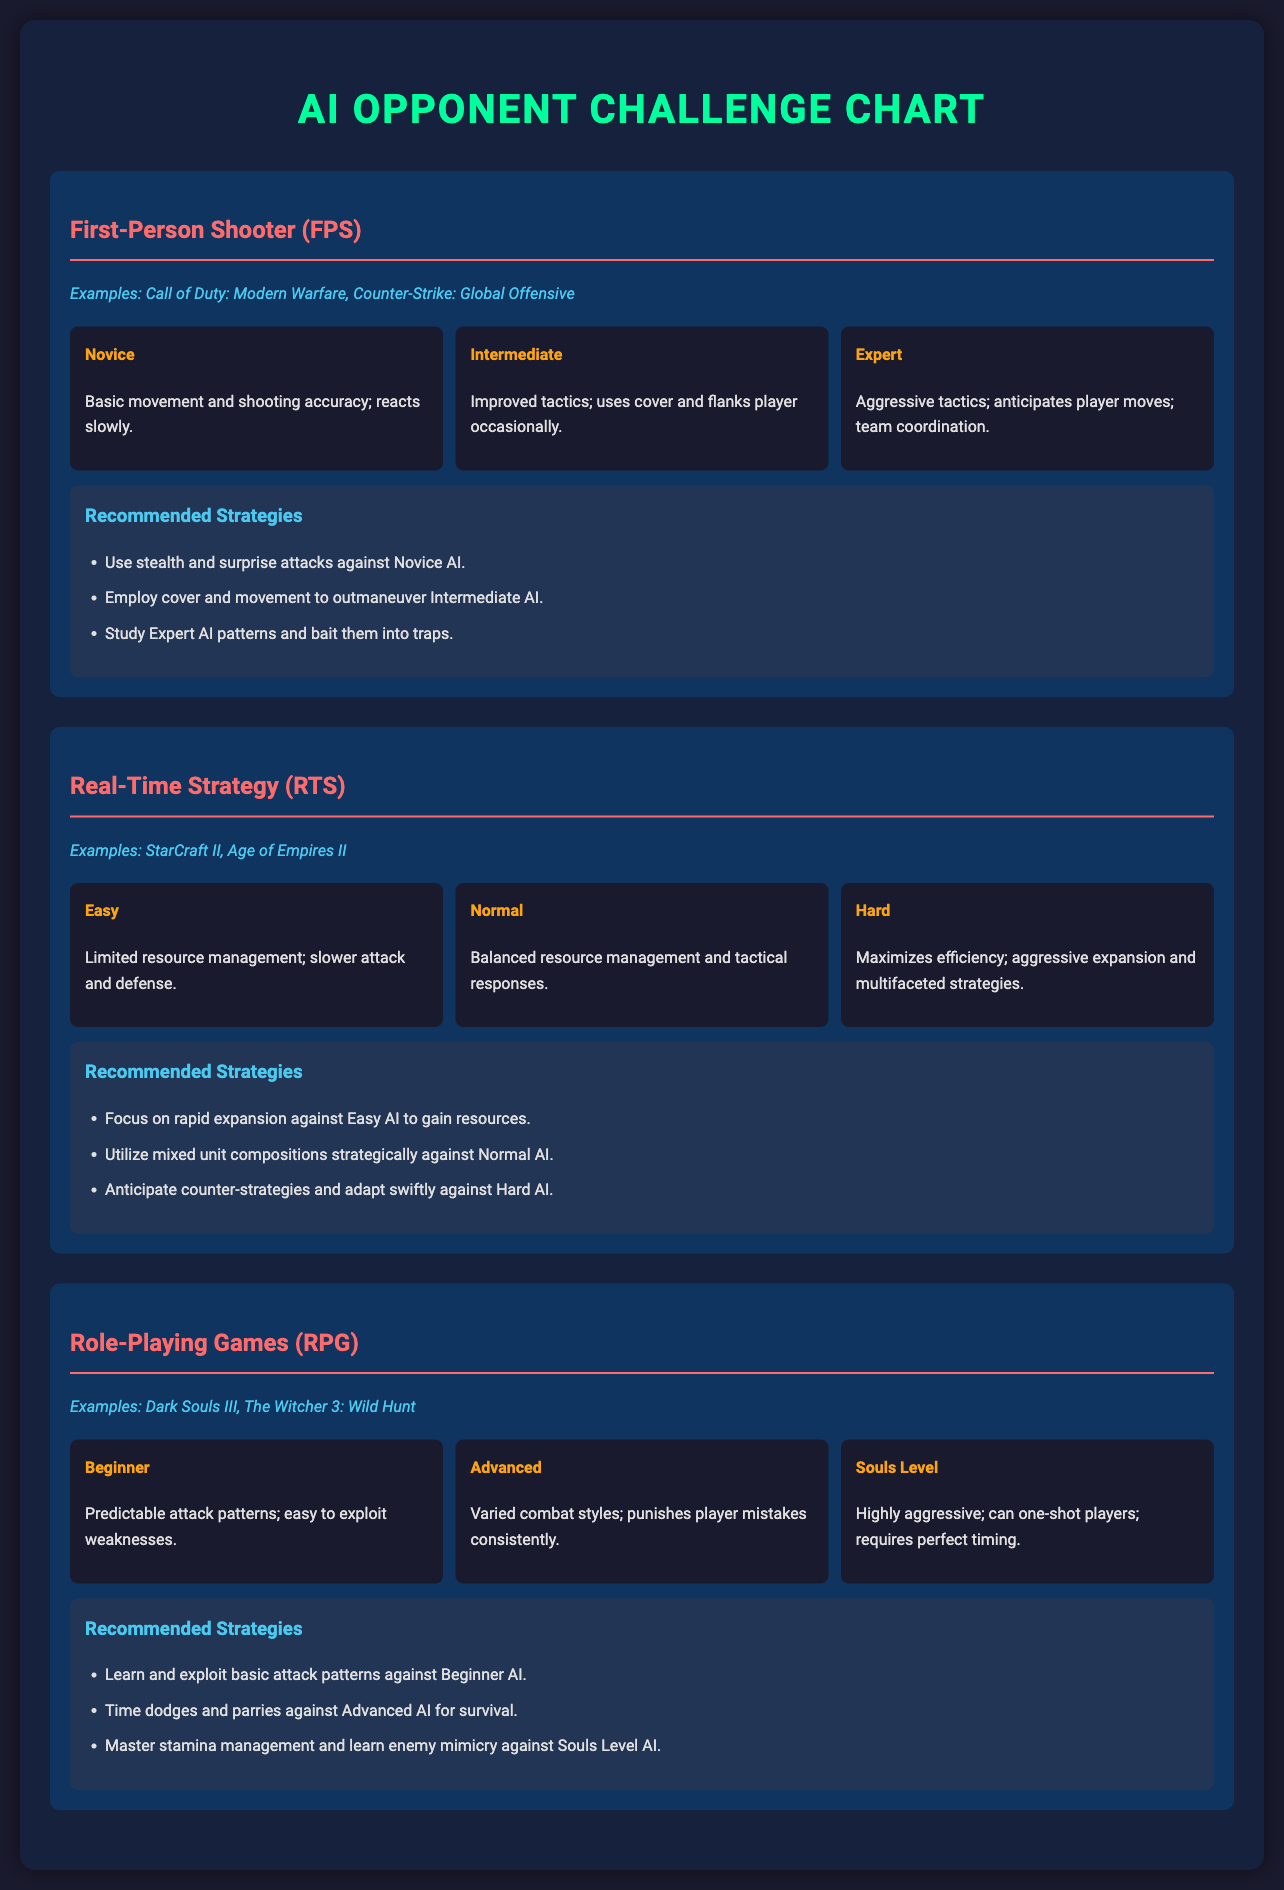What are the examples of FPS games? The examples of FPS games listed in the document include Call of Duty: Modern Warfare and Counter-Strike: Global Offensive.
Answer: Call of Duty: Modern Warfare, Counter-Strike: Global Offensive What is the highest difficulty level in RPG? The document states that the highest difficulty level in RPG is Souls Level, which is characterized by highly aggressive AI that can one-shot players.
Answer: Souls Level What strategy is recommended against Intermediate AI in FPS? The document suggests employing cover and movement to outmaneuver Intermediate AI in FPS games.
Answer: Employ cover and movement What is the attack pattern characteristic of Beginner AI in RPG? According to the document, Beginner AI in RPG has predictable attack patterns that are easy to exploit.
Answer: Predictable attack patterns How many difficulty levels are listed for RTS games? The document includes three difficulty levels for RTS games: Easy, Normal, and Hard.
Answer: Three What is the recommended strategy against Hard AI in RTS? The recommended strategy against Hard AI in RTS is to anticipate counter-strategies and adapt swiftly.
Answer: Anticipate counter-strategies What color is used for the genre headings? The genre headings in the document are colored in red.
Answer: Red What type of game is characterized by aggressive tactics that anticipate player moves? The document indicates that Expert AI in FPS is characterized by aggressive tactics that anticipate player moves.
Answer: Expert AI What is a key characteristic of Hard difficulty in RTS? The document states that Hard difficulty in RTS maximizes efficiency with aggressive expansion and multifaceted strategies.
Answer: Maximizes efficiency 